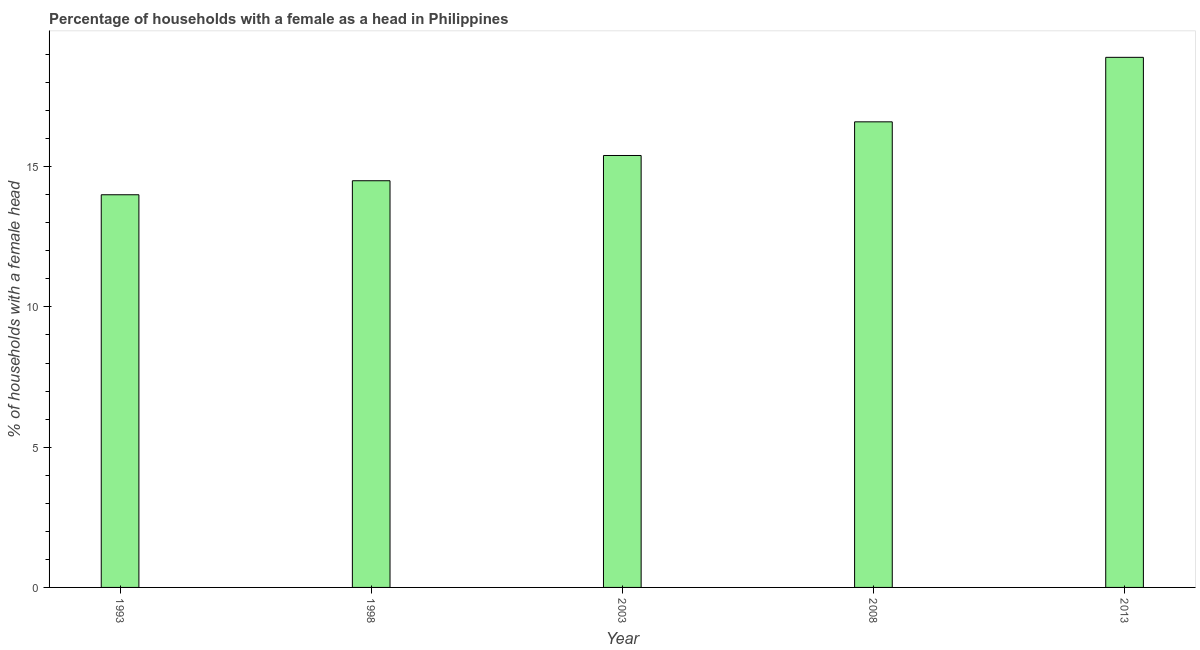Does the graph contain any zero values?
Ensure brevity in your answer.  No. What is the title of the graph?
Make the answer very short. Percentage of households with a female as a head in Philippines. What is the label or title of the Y-axis?
Give a very brief answer. % of households with a female head. What is the number of female supervised households in 1993?
Ensure brevity in your answer.  14. Across all years, what is the minimum number of female supervised households?
Provide a succinct answer. 14. What is the sum of the number of female supervised households?
Your response must be concise. 79.4. What is the average number of female supervised households per year?
Give a very brief answer. 15.88. Do a majority of the years between 2008 and 1993 (inclusive) have number of female supervised households greater than 18 %?
Your answer should be compact. Yes. What is the ratio of the number of female supervised households in 1998 to that in 2003?
Your response must be concise. 0.94. What is the difference between the highest and the second highest number of female supervised households?
Provide a succinct answer. 2.3. Are all the bars in the graph horizontal?
Keep it short and to the point. No. What is the difference between two consecutive major ticks on the Y-axis?
Your answer should be very brief. 5. Are the values on the major ticks of Y-axis written in scientific E-notation?
Offer a very short reply. No. What is the % of households with a female head in 1993?
Your response must be concise. 14. What is the % of households with a female head in 1998?
Ensure brevity in your answer.  14.5. What is the difference between the % of households with a female head in 1993 and 1998?
Give a very brief answer. -0.5. What is the difference between the % of households with a female head in 1993 and 2008?
Provide a succinct answer. -2.6. What is the difference between the % of households with a female head in 1998 and 2003?
Provide a succinct answer. -0.9. What is the difference between the % of households with a female head in 1998 and 2008?
Provide a short and direct response. -2.1. What is the difference between the % of households with a female head in 2003 and 2008?
Keep it short and to the point. -1.2. What is the ratio of the % of households with a female head in 1993 to that in 1998?
Provide a succinct answer. 0.97. What is the ratio of the % of households with a female head in 1993 to that in 2003?
Offer a very short reply. 0.91. What is the ratio of the % of households with a female head in 1993 to that in 2008?
Give a very brief answer. 0.84. What is the ratio of the % of households with a female head in 1993 to that in 2013?
Ensure brevity in your answer.  0.74. What is the ratio of the % of households with a female head in 1998 to that in 2003?
Your answer should be compact. 0.94. What is the ratio of the % of households with a female head in 1998 to that in 2008?
Your response must be concise. 0.87. What is the ratio of the % of households with a female head in 1998 to that in 2013?
Your response must be concise. 0.77. What is the ratio of the % of households with a female head in 2003 to that in 2008?
Keep it short and to the point. 0.93. What is the ratio of the % of households with a female head in 2003 to that in 2013?
Provide a succinct answer. 0.81. What is the ratio of the % of households with a female head in 2008 to that in 2013?
Offer a very short reply. 0.88. 